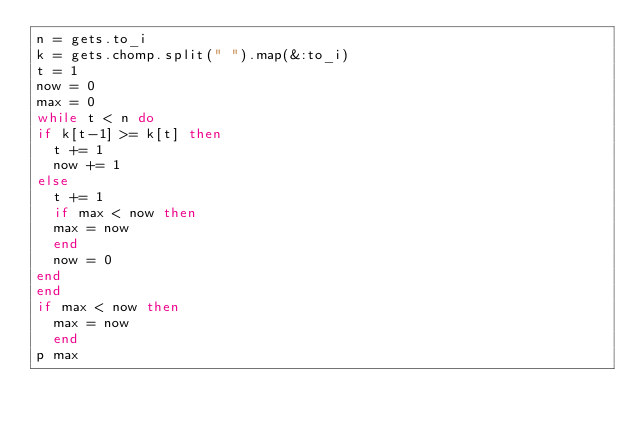Convert code to text. <code><loc_0><loc_0><loc_500><loc_500><_Ruby_>n = gets.to_i
k = gets.chomp.split(" ").map(&:to_i)
t = 1
now = 0
max = 0
while t < n do
if k[t-1] >= k[t] then
  t += 1
  now += 1
else 
  t += 1
  if max < now then
  max = now
  end
  now = 0
end
end
if max < now then
  max = now
  end
p max
</code> 